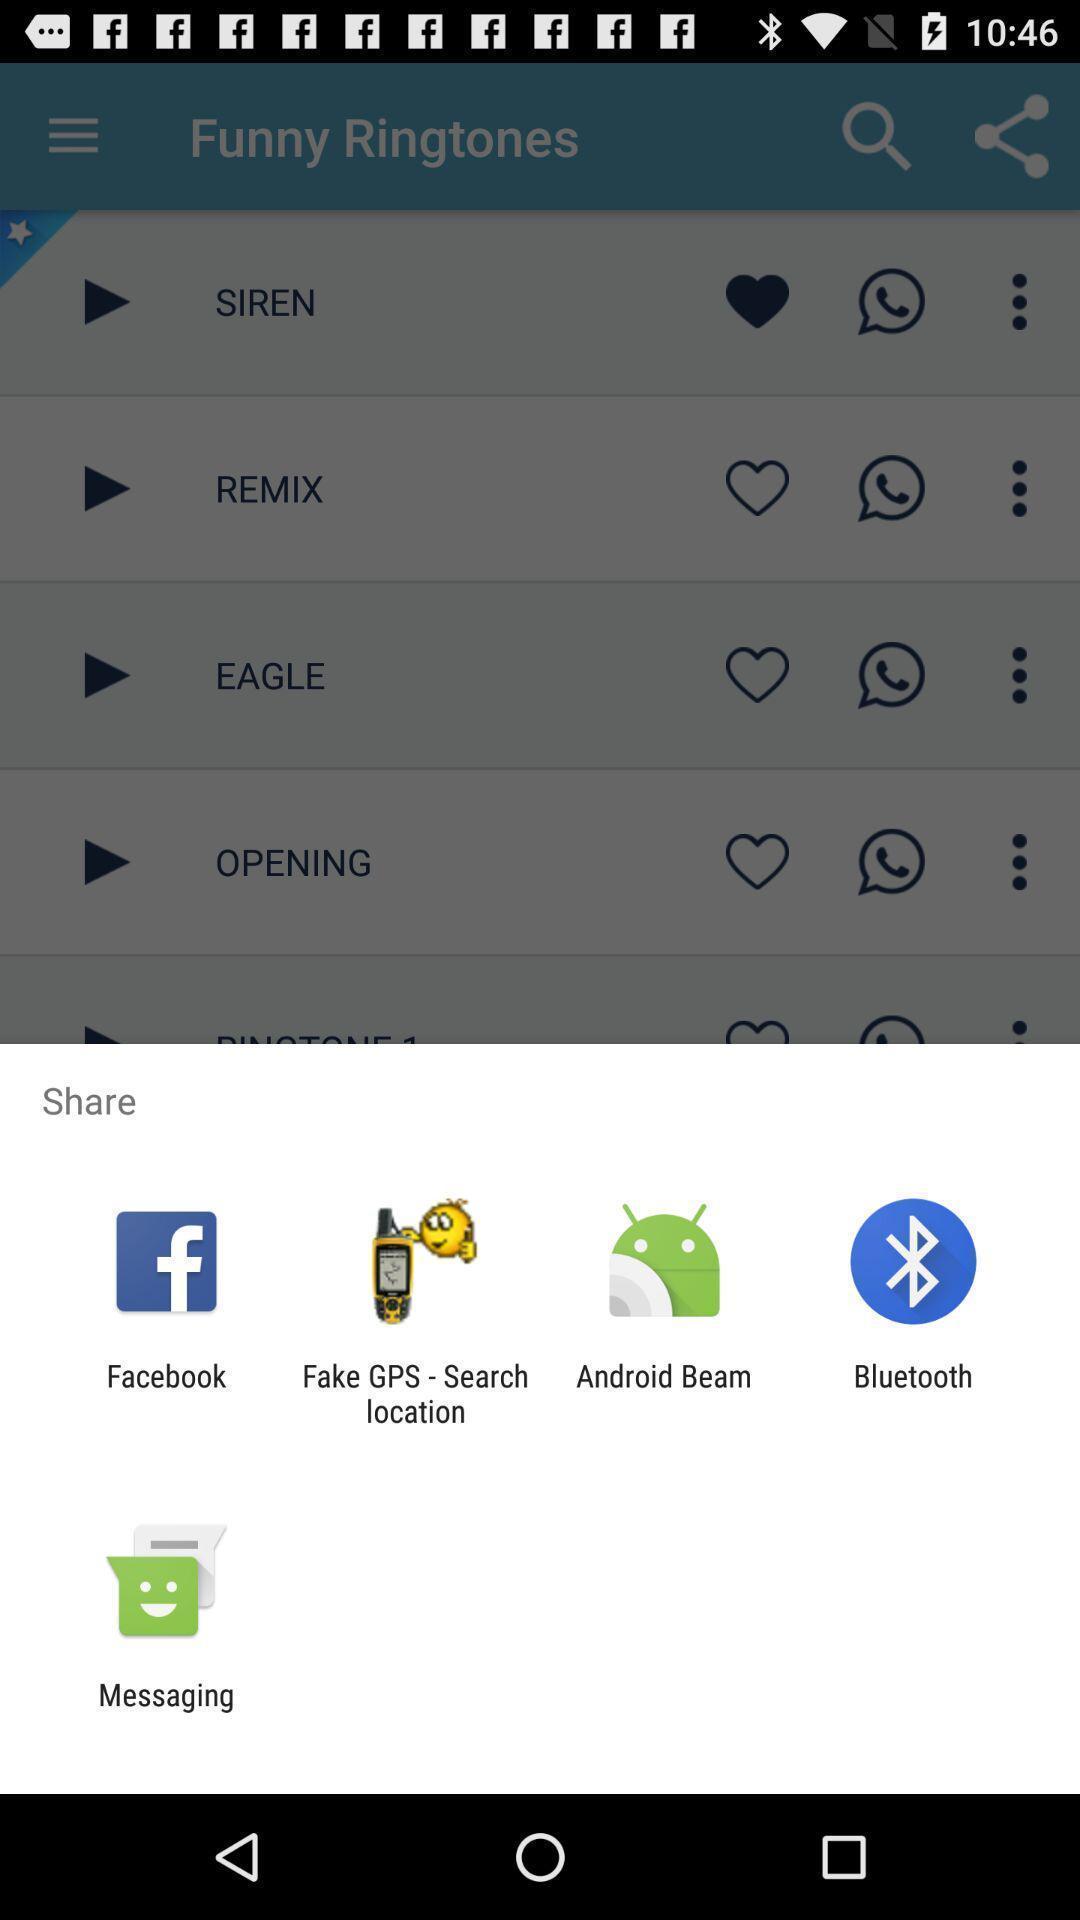Summarize the main components in this picture. Pop-up shows to share with multiple apps. 